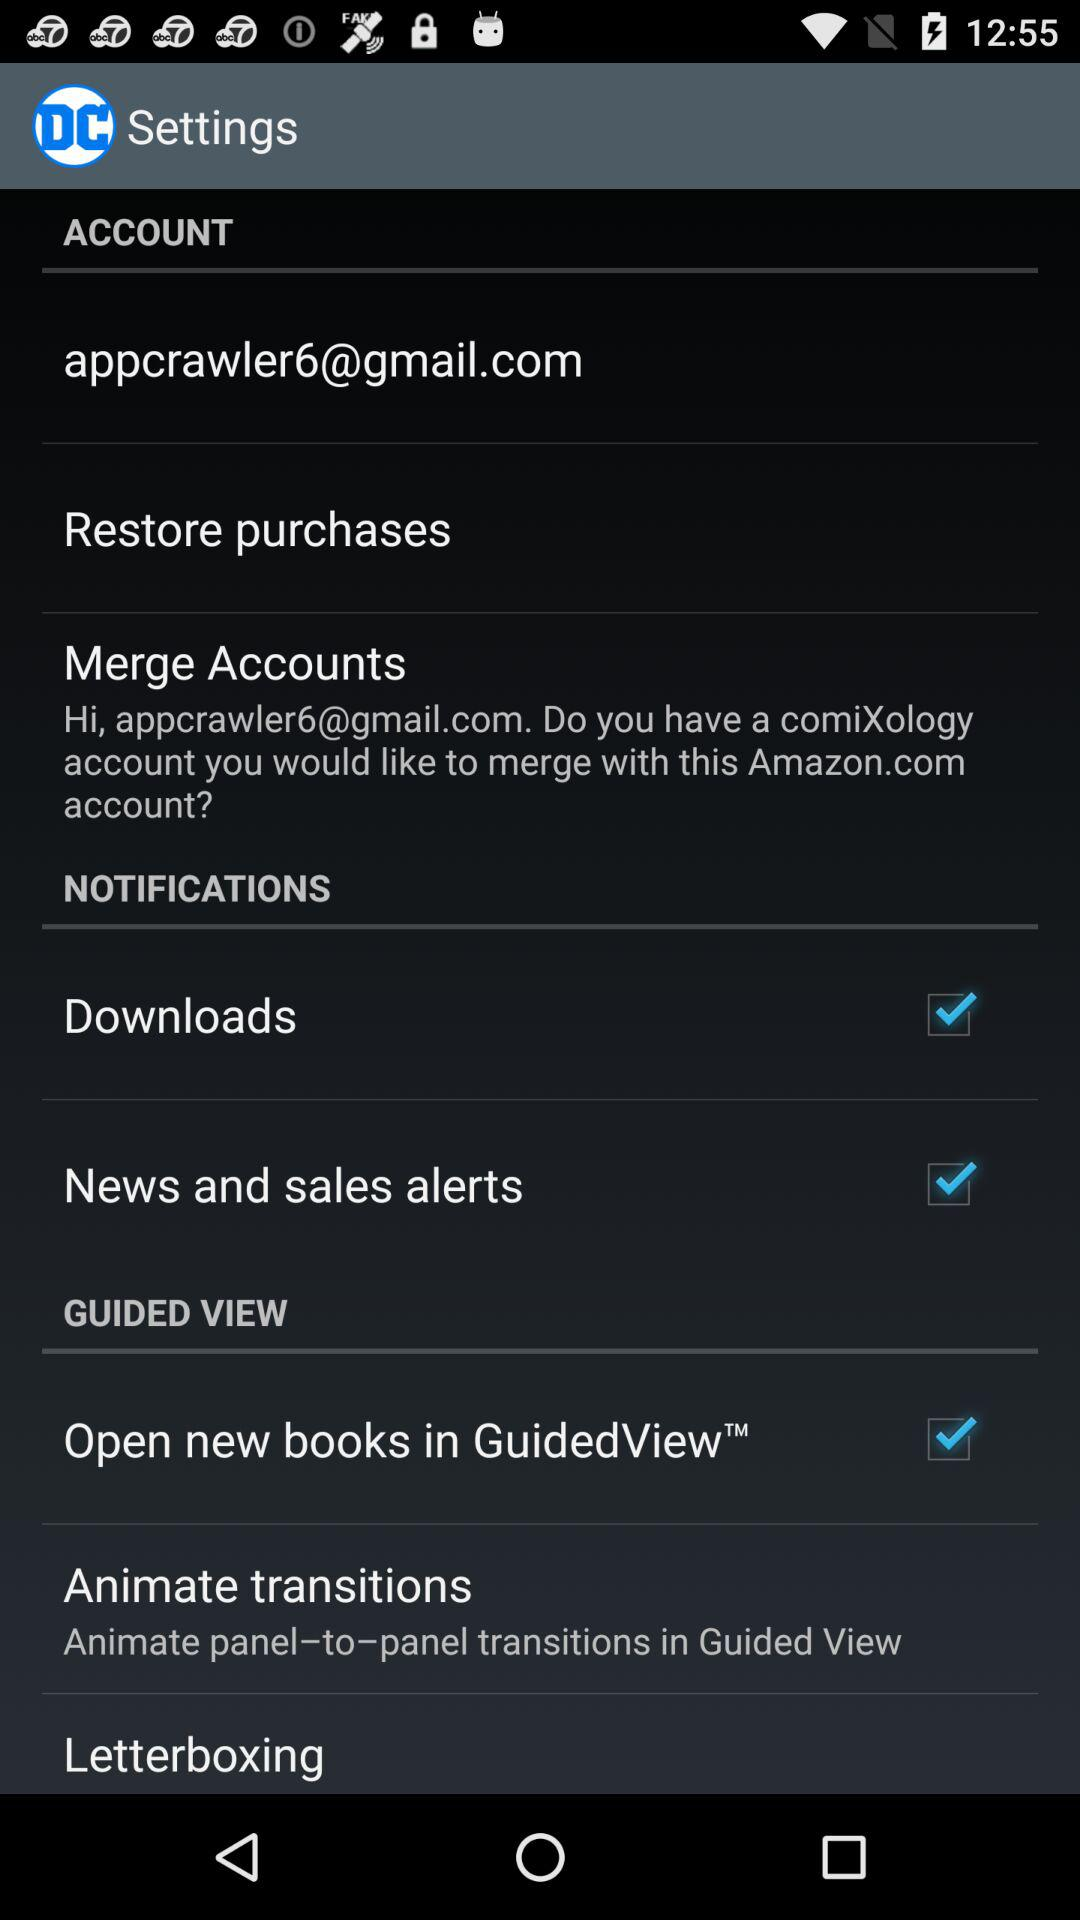What is the description given in the "Animate transitions"? The description is: "Animate panel–to–panel transitions in Guided View". 